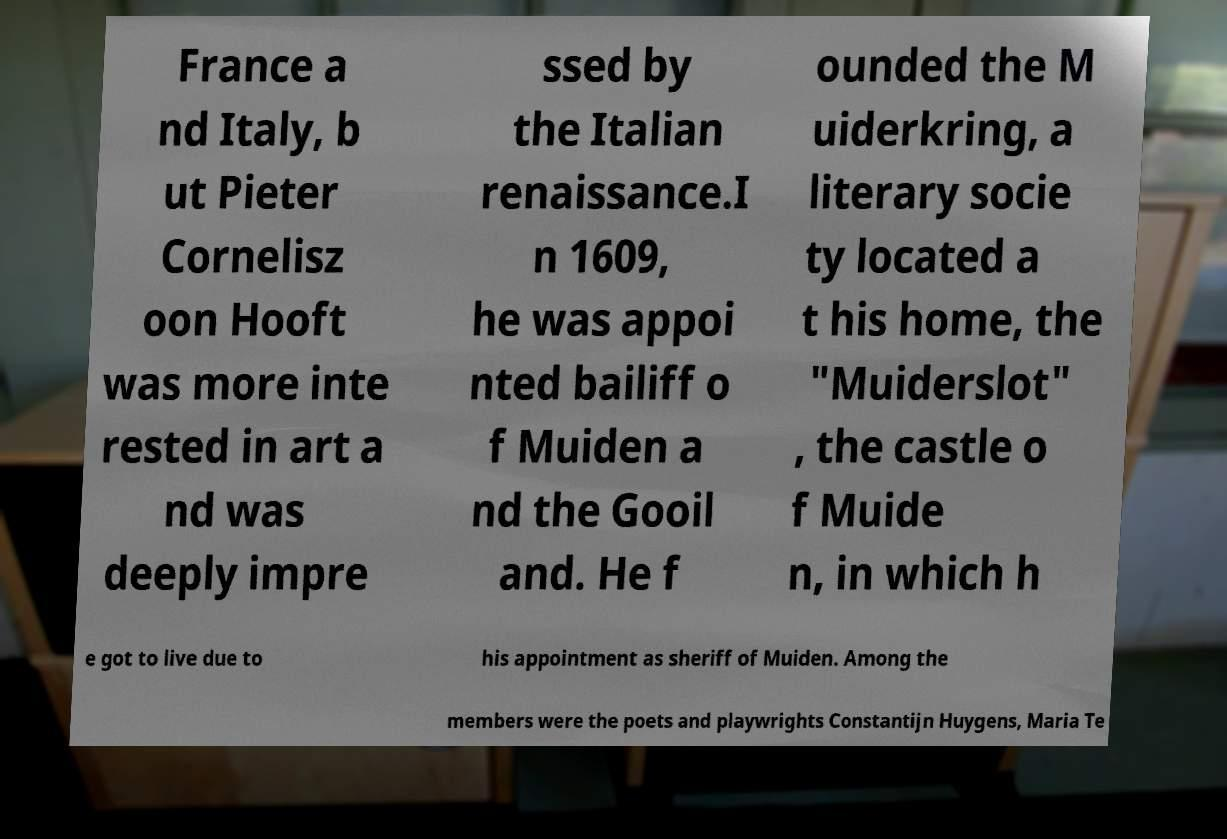Please identify and transcribe the text found in this image. France a nd Italy, b ut Pieter Cornelisz oon Hooft was more inte rested in art a nd was deeply impre ssed by the Italian renaissance.I n 1609, he was appoi nted bailiff o f Muiden a nd the Gooil and. He f ounded the M uiderkring, a literary socie ty located a t his home, the "Muiderslot" , the castle o f Muide n, in which h e got to live due to his appointment as sheriff of Muiden. Among the members were the poets and playwrights Constantijn Huygens, Maria Te 